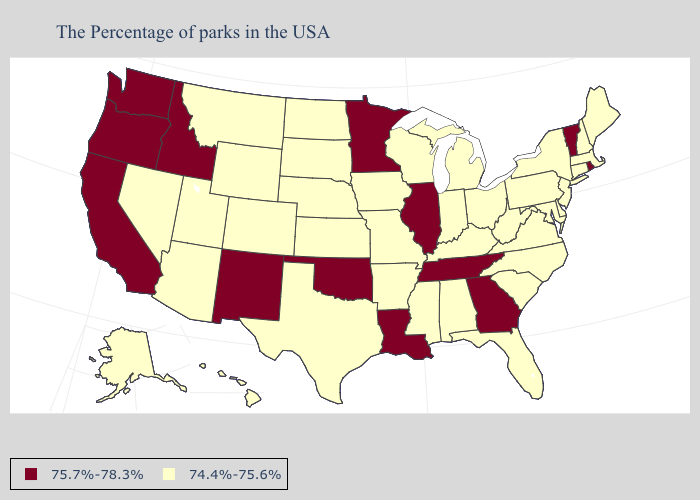Does Ohio have the same value as Missouri?
Keep it brief. Yes. What is the lowest value in the MidWest?
Answer briefly. 74.4%-75.6%. Does the map have missing data?
Be succinct. No. Among the states that border Massachusetts , which have the highest value?
Concise answer only. Rhode Island, Vermont. What is the value of Nebraska?
Give a very brief answer. 74.4%-75.6%. What is the value of Ohio?
Give a very brief answer. 74.4%-75.6%. Name the states that have a value in the range 74.4%-75.6%?
Answer briefly. Maine, Massachusetts, New Hampshire, Connecticut, New York, New Jersey, Delaware, Maryland, Pennsylvania, Virginia, North Carolina, South Carolina, West Virginia, Ohio, Florida, Michigan, Kentucky, Indiana, Alabama, Wisconsin, Mississippi, Missouri, Arkansas, Iowa, Kansas, Nebraska, Texas, South Dakota, North Dakota, Wyoming, Colorado, Utah, Montana, Arizona, Nevada, Alaska, Hawaii. What is the value of Utah?
Write a very short answer. 74.4%-75.6%. What is the highest value in the South ?
Concise answer only. 75.7%-78.3%. Name the states that have a value in the range 74.4%-75.6%?
Quick response, please. Maine, Massachusetts, New Hampshire, Connecticut, New York, New Jersey, Delaware, Maryland, Pennsylvania, Virginia, North Carolina, South Carolina, West Virginia, Ohio, Florida, Michigan, Kentucky, Indiana, Alabama, Wisconsin, Mississippi, Missouri, Arkansas, Iowa, Kansas, Nebraska, Texas, South Dakota, North Dakota, Wyoming, Colorado, Utah, Montana, Arizona, Nevada, Alaska, Hawaii. What is the highest value in states that border Ohio?
Be succinct. 74.4%-75.6%. What is the value of Maryland?
Keep it brief. 74.4%-75.6%. Which states have the lowest value in the USA?
Be succinct. Maine, Massachusetts, New Hampshire, Connecticut, New York, New Jersey, Delaware, Maryland, Pennsylvania, Virginia, North Carolina, South Carolina, West Virginia, Ohio, Florida, Michigan, Kentucky, Indiana, Alabama, Wisconsin, Mississippi, Missouri, Arkansas, Iowa, Kansas, Nebraska, Texas, South Dakota, North Dakota, Wyoming, Colorado, Utah, Montana, Arizona, Nevada, Alaska, Hawaii. What is the value of North Carolina?
Write a very short answer. 74.4%-75.6%. What is the value of Hawaii?
Keep it brief. 74.4%-75.6%. 